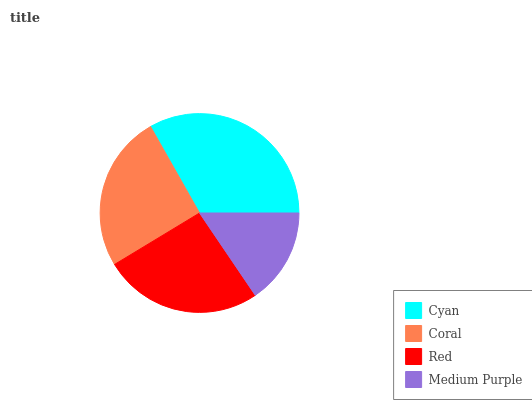Is Medium Purple the minimum?
Answer yes or no. Yes. Is Cyan the maximum?
Answer yes or no. Yes. Is Coral the minimum?
Answer yes or no. No. Is Coral the maximum?
Answer yes or no. No. Is Cyan greater than Coral?
Answer yes or no. Yes. Is Coral less than Cyan?
Answer yes or no. Yes. Is Coral greater than Cyan?
Answer yes or no. No. Is Cyan less than Coral?
Answer yes or no. No. Is Red the high median?
Answer yes or no. Yes. Is Coral the low median?
Answer yes or no. Yes. Is Medium Purple the high median?
Answer yes or no. No. Is Cyan the low median?
Answer yes or no. No. 